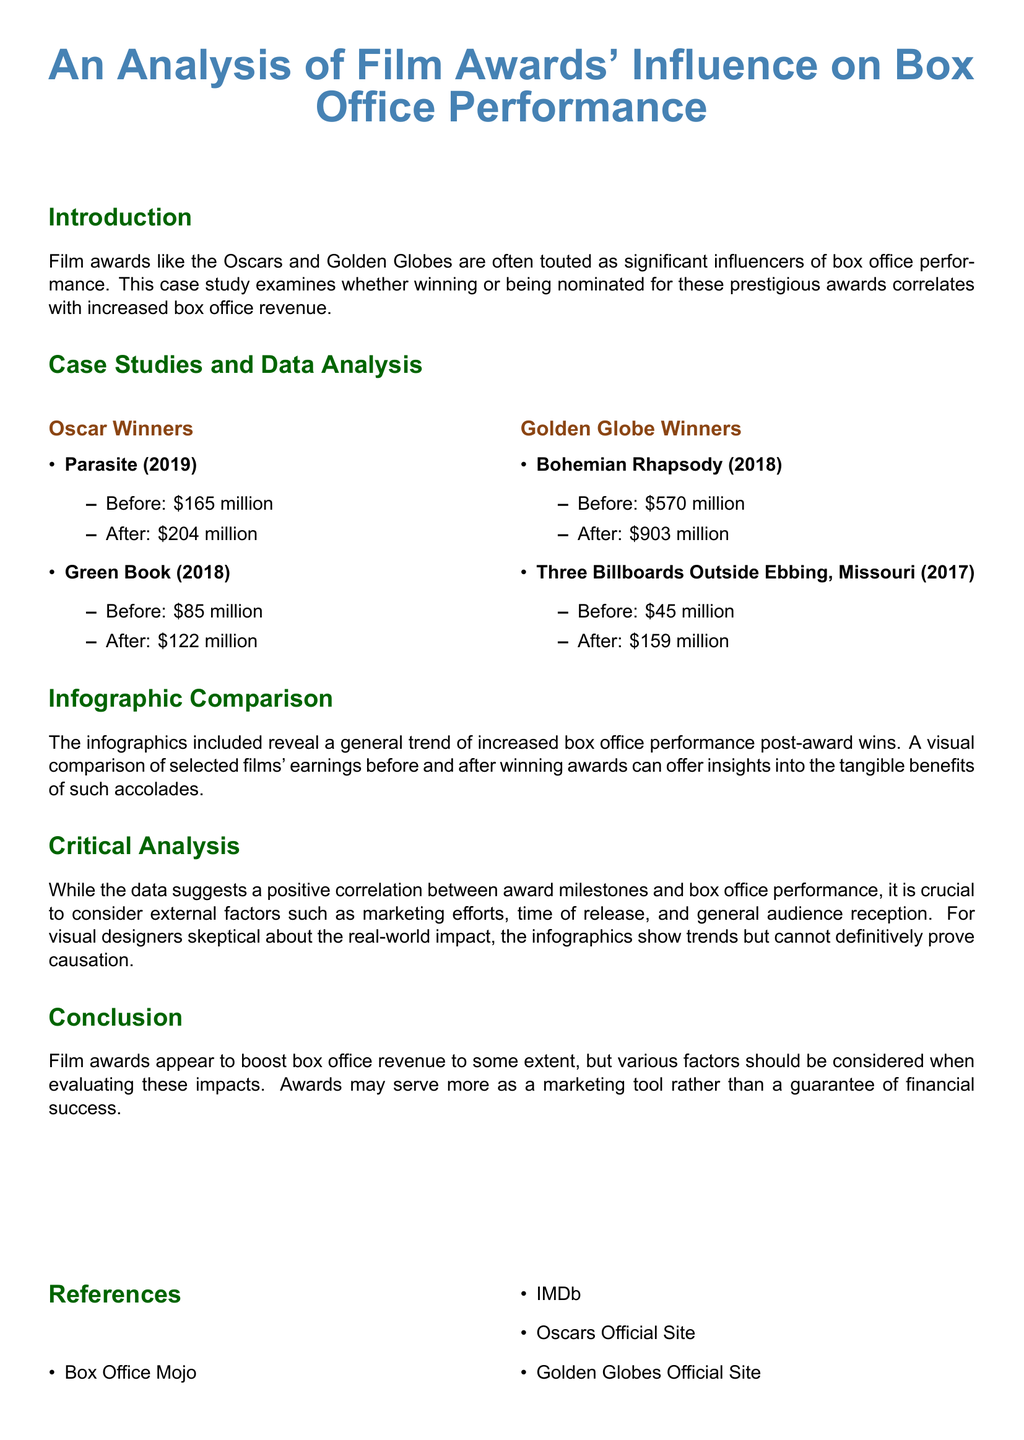What is the box office revenue for Parasite before winning an Oscar? The document states that Parasite had a box office revenue of $165 million before winning the Oscar.
Answer: $165 million What is the box office revenue for Bohemian Rhapsody after winning a Golden Globe? According to the document, Bohemian Rhapsody earned $903 million after winning a Golden Globe.
Answer: $903 million Which film's box office revenue increased by the largest amount after receiving an award? By analyzing the changes in box office revenue, Bohemian Rhapsody saw the largest increase, from $570 million to $903 million.
Answer: Bohemian Rhapsody What is the total box office revenue for Green Book after winning an Oscar? The document notes that after winning the Oscar, Green Book's revenue was $122 million.
Answer: $122 million How many films were analyzed in the Oscar Winners section? The document lists two films: Parasite and Green Book in the Oscar Winners section.
Answer: Two Do the infographics suggest a direct causation between awards and box office performance? The document states that while there is a positive correlation, it cannot definitively prove causation between awards and box office performance.
Answer: No What type of document is this? Based on its structure and content, this is a case study focusing on film awards and box office performance.
Answer: Case study Which two awards are discussed in the analysis? The document specifically mentions the Oscars and the Golden Globes as the awards analyzed.
Answer: Oscars and Golden Globes What year did Green Book win an Oscar? Green Book is noted to have won an Oscar in 2018 according to the document.
Answer: 2018 